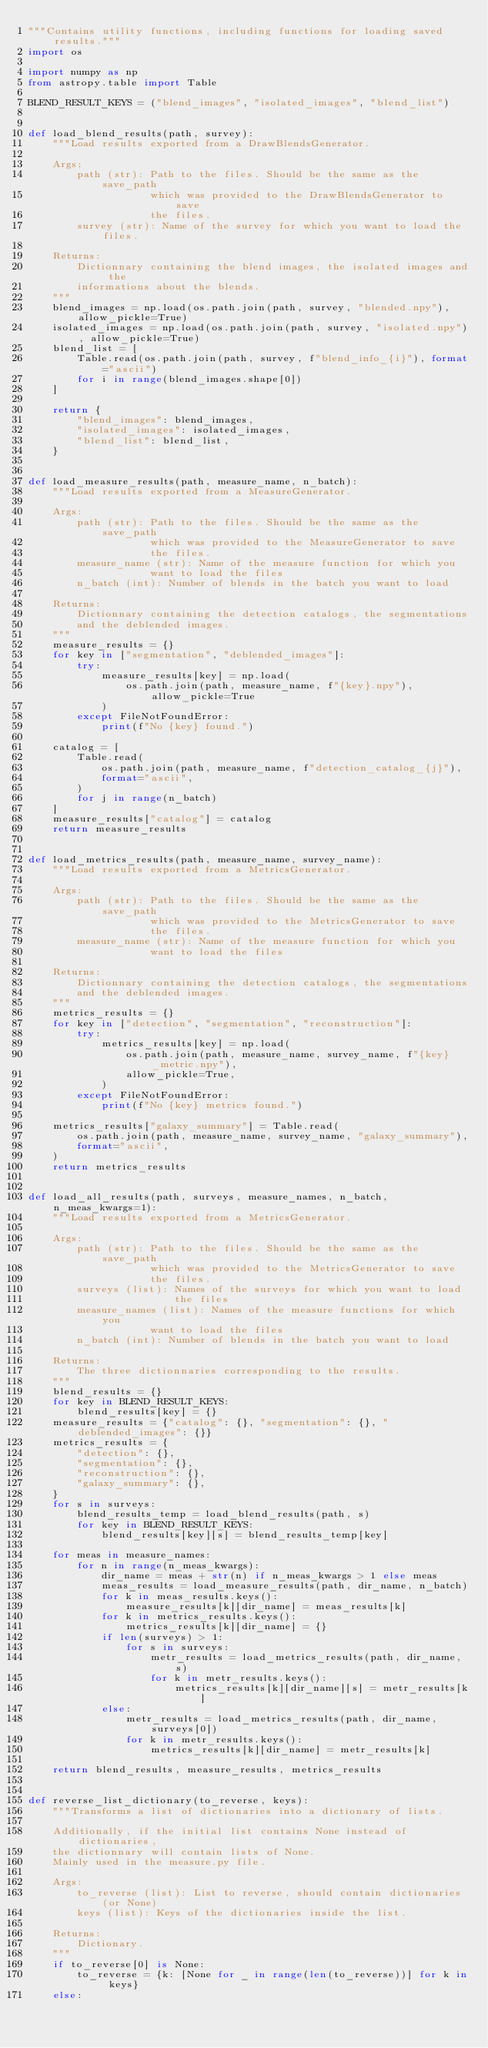<code> <loc_0><loc_0><loc_500><loc_500><_Python_>"""Contains utility functions, including functions for loading saved results."""
import os

import numpy as np
from astropy.table import Table

BLEND_RESULT_KEYS = ("blend_images", "isolated_images", "blend_list")


def load_blend_results(path, survey):
    """Load results exported from a DrawBlendsGenerator.

    Args;
        path (str): Path to the files. Should be the same as the save_path
                    which was provided to the DrawBlendsGenerator to save
                    the files.
        survey (str): Name of the survey for which you want to load the files.

    Returns:
        Dictionnary containing the blend images, the isolated images and the
        informations about the blends.
    """
    blend_images = np.load(os.path.join(path, survey, "blended.npy"), allow_pickle=True)
    isolated_images = np.load(os.path.join(path, survey, "isolated.npy"), allow_pickle=True)
    blend_list = [
        Table.read(os.path.join(path, survey, f"blend_info_{i}"), format="ascii")
        for i in range(blend_images.shape[0])
    ]

    return {
        "blend_images": blend_images,
        "isolated_images": isolated_images,
        "blend_list": blend_list,
    }


def load_measure_results(path, measure_name, n_batch):
    """Load results exported from a MeasureGenerator.

    Args:
        path (str): Path to the files. Should be the same as the save_path
                    which was provided to the MeasureGenerator to save
                    the files.
        measure_name (str): Name of the measure function for which you
                    want to load the files
        n_batch (int): Number of blends in the batch you want to load

    Returns:
        Dictionnary containing the detection catalogs, the segmentations
        and the deblended images.
    """
    measure_results = {}
    for key in ["segmentation", "deblended_images"]:
        try:
            measure_results[key] = np.load(
                os.path.join(path, measure_name, f"{key}.npy"), allow_pickle=True
            )
        except FileNotFoundError:
            print(f"No {key} found.")

    catalog = [
        Table.read(
            os.path.join(path, measure_name, f"detection_catalog_{j}"),
            format="ascii",
        )
        for j in range(n_batch)
    ]
    measure_results["catalog"] = catalog
    return measure_results


def load_metrics_results(path, measure_name, survey_name):
    """Load results exported from a MetricsGenerator.

    Args:
        path (str): Path to the files. Should be the same as the save_path
                    which was provided to the MetricsGenerator to save
                    the files.
        measure_name (str): Name of the measure function for which you
                    want to load the files

    Returns:
        Dictionnary containing the detection catalogs, the segmentations
        and the deblended images.
    """
    metrics_results = {}
    for key in ["detection", "segmentation", "reconstruction"]:
        try:
            metrics_results[key] = np.load(
                os.path.join(path, measure_name, survey_name, f"{key}_metric.npy"),
                allow_pickle=True,
            )
        except FileNotFoundError:
            print(f"No {key} metrics found.")

    metrics_results["galaxy_summary"] = Table.read(
        os.path.join(path, measure_name, survey_name, "galaxy_summary"),
        format="ascii",
    )
    return metrics_results


def load_all_results(path, surveys, measure_names, n_batch, n_meas_kwargs=1):
    """Load results exported from a MetricsGenerator.

    Args:
        path (str): Path to the files. Should be the same as the save_path
                    which was provided to the MetricsGenerator to save
                    the files.
        surveys (list): Names of the surveys for which you want to load
                        the files
        measure_names (list): Names of the measure functions for which you
                    want to load the files
        n_batch (int): Number of blends in the batch you want to load

    Returns:
        The three dictionnaries corresponding to the results.
    """
    blend_results = {}
    for key in BLEND_RESULT_KEYS:
        blend_results[key] = {}
    measure_results = {"catalog": {}, "segmentation": {}, "deblended_images": {}}
    metrics_results = {
        "detection": {},
        "segmentation": {},
        "reconstruction": {},
        "galaxy_summary": {},
    }
    for s in surveys:
        blend_results_temp = load_blend_results(path, s)
        for key in BLEND_RESULT_KEYS:
            blend_results[key][s] = blend_results_temp[key]

    for meas in measure_names:
        for n in range(n_meas_kwargs):
            dir_name = meas + str(n) if n_meas_kwargs > 1 else meas
            meas_results = load_measure_results(path, dir_name, n_batch)
            for k in meas_results.keys():
                measure_results[k][dir_name] = meas_results[k]
            for k in metrics_results.keys():
                metrics_results[k][dir_name] = {}
            if len(surveys) > 1:
                for s in surveys:
                    metr_results = load_metrics_results(path, dir_name, s)
                    for k in metr_results.keys():
                        metrics_results[k][dir_name][s] = metr_results[k]
            else:
                metr_results = load_metrics_results(path, dir_name, surveys[0])
                for k in metr_results.keys():
                    metrics_results[k][dir_name] = metr_results[k]

    return blend_results, measure_results, metrics_results


def reverse_list_dictionary(to_reverse, keys):
    """Transforms a list of dictionaries into a dictionary of lists.

    Additionally, if the initial list contains None instead of dictionaries,
    the dictionnary will contain lists of None.
    Mainly used in the measure.py file.

    Args:
        to_reverse (list): List to reverse, should contain dictionaries (or None)
        keys (list): Keys of the dictionaries inside the list.

    Returns:
        Dictionary.
    """
    if to_reverse[0] is None:
        to_reverse = {k: [None for _ in range(len(to_reverse))] for k in keys}
    else:</code> 